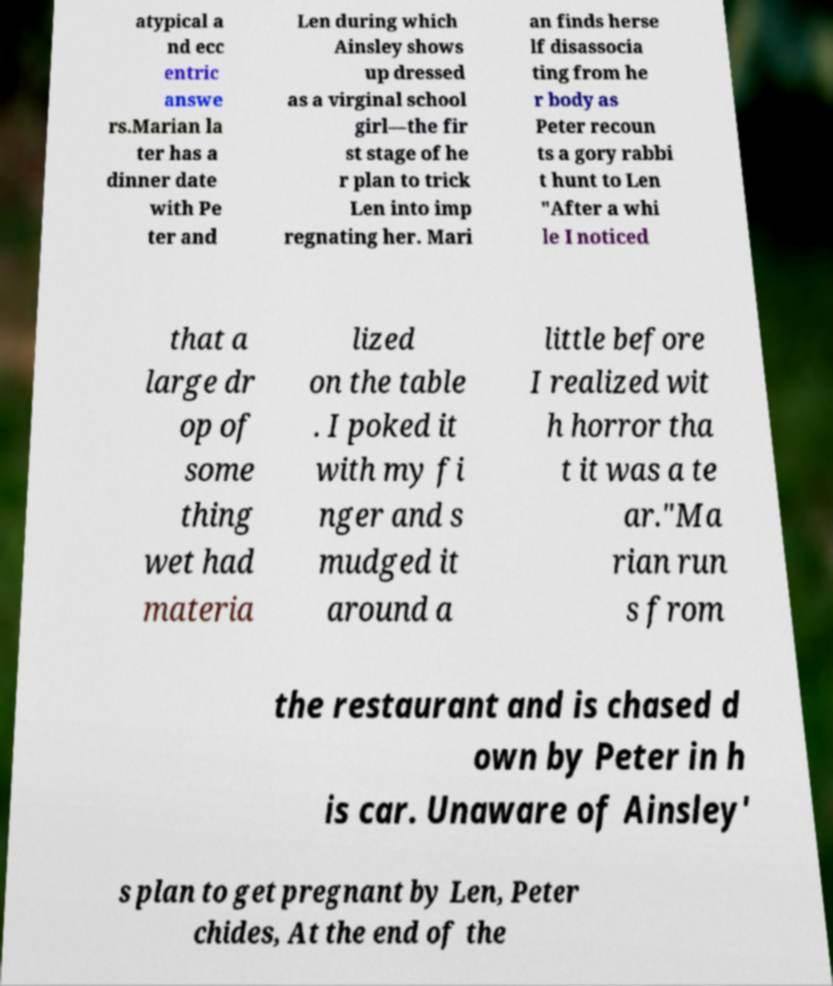Could you extract and type out the text from this image? atypical a nd ecc entric answe rs.Marian la ter has a dinner date with Pe ter and Len during which Ainsley shows up dressed as a virginal school girl—the fir st stage of he r plan to trick Len into imp regnating her. Mari an finds herse lf disassocia ting from he r body as Peter recoun ts a gory rabbi t hunt to Len "After a whi le I noticed that a large dr op of some thing wet had materia lized on the table . I poked it with my fi nger and s mudged it around a little before I realized wit h horror tha t it was a te ar."Ma rian run s from the restaurant and is chased d own by Peter in h is car. Unaware of Ainsley' s plan to get pregnant by Len, Peter chides, At the end of the 